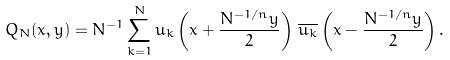<formula> <loc_0><loc_0><loc_500><loc_500>Q _ { N } ( x , y ) = N ^ { - 1 } \sum _ { k = 1 } ^ { N } u _ { k } \left ( x + \frac { N ^ { - 1 / n } y } { 2 } \right ) \, \overline { u _ { k } } \left ( x - \frac { N ^ { - 1 / n } y } { 2 } \right ) .</formula> 